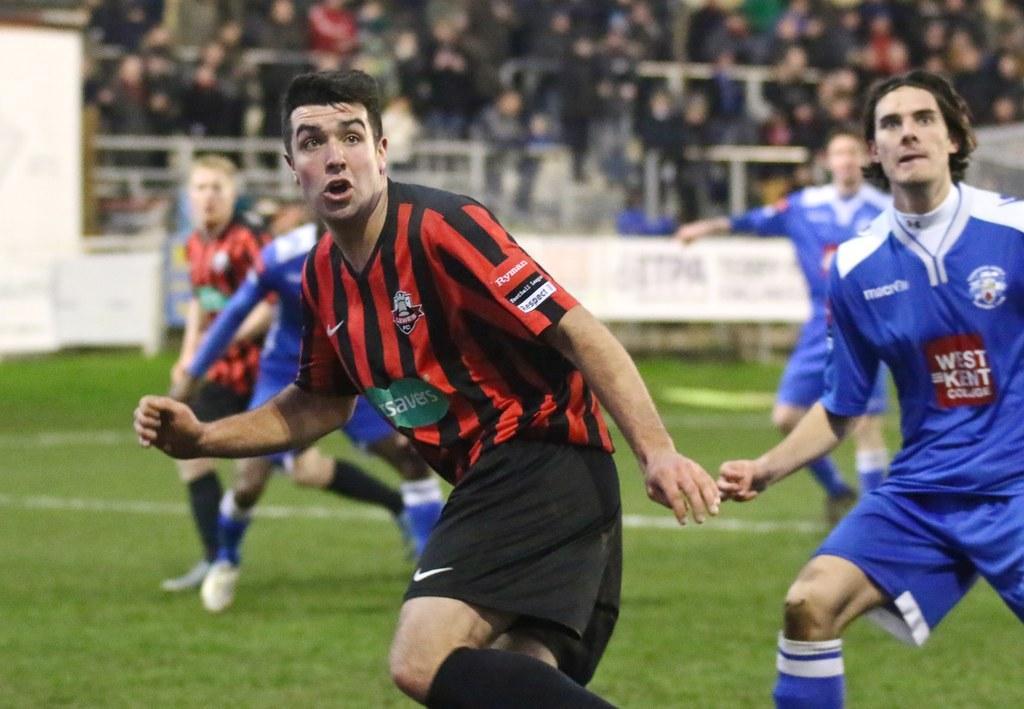Could you give a brief overview of what you see in this image? There are few persons wearing blue and red dress are running on a greenery ground and there are few audience in the background. 